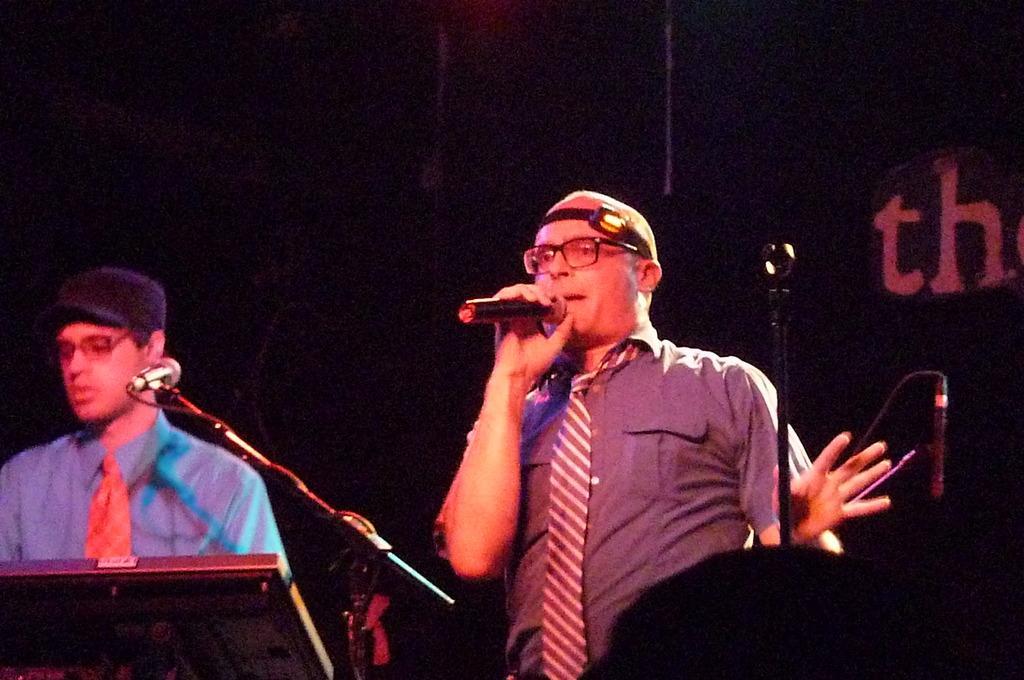Please provide a concise description of this image. There are two people in the image. One person standing and holding a microphone and opened his mouth for singing another person left side sitting on chair and playing his musical instrument in front of a microphone. 